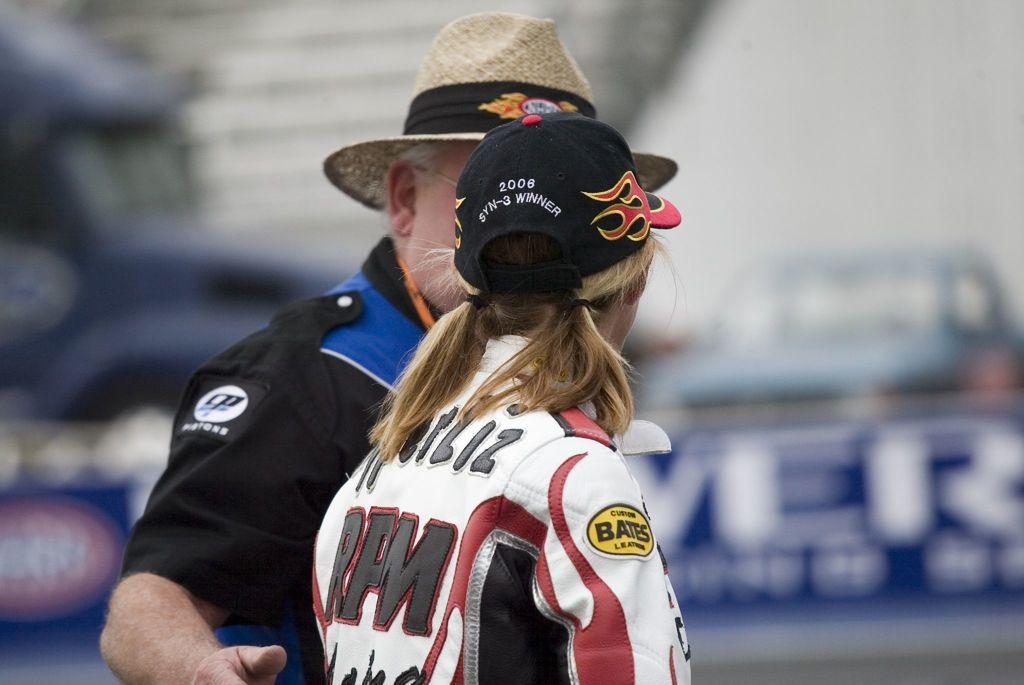What initials are on the back of the shirt worn by the person in the middle?
Keep it short and to the point. Rpm. In what year was the athlete the syn-3?
Your response must be concise. 2006. 